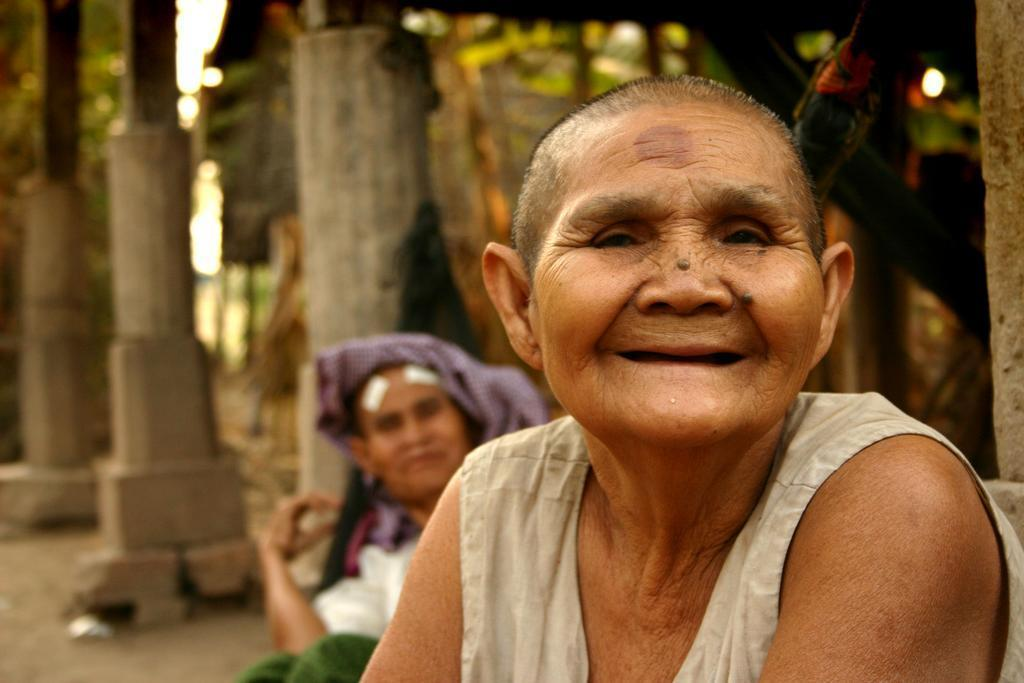What is the main subject of the image? The main subject of the image is old women seated. Can you describe the clothing of one of the women? One woman is wearing a cloth on her head. What architectural features can be seen in the image? There are pillars visible in the image. What type of structure might be visible in the background? There appears to be a house in the background of the image. How many waves can be seen crashing on the seashore in the image? There is no seashore or waves present in the image; it features old women seated with pillars and a house in the background. 